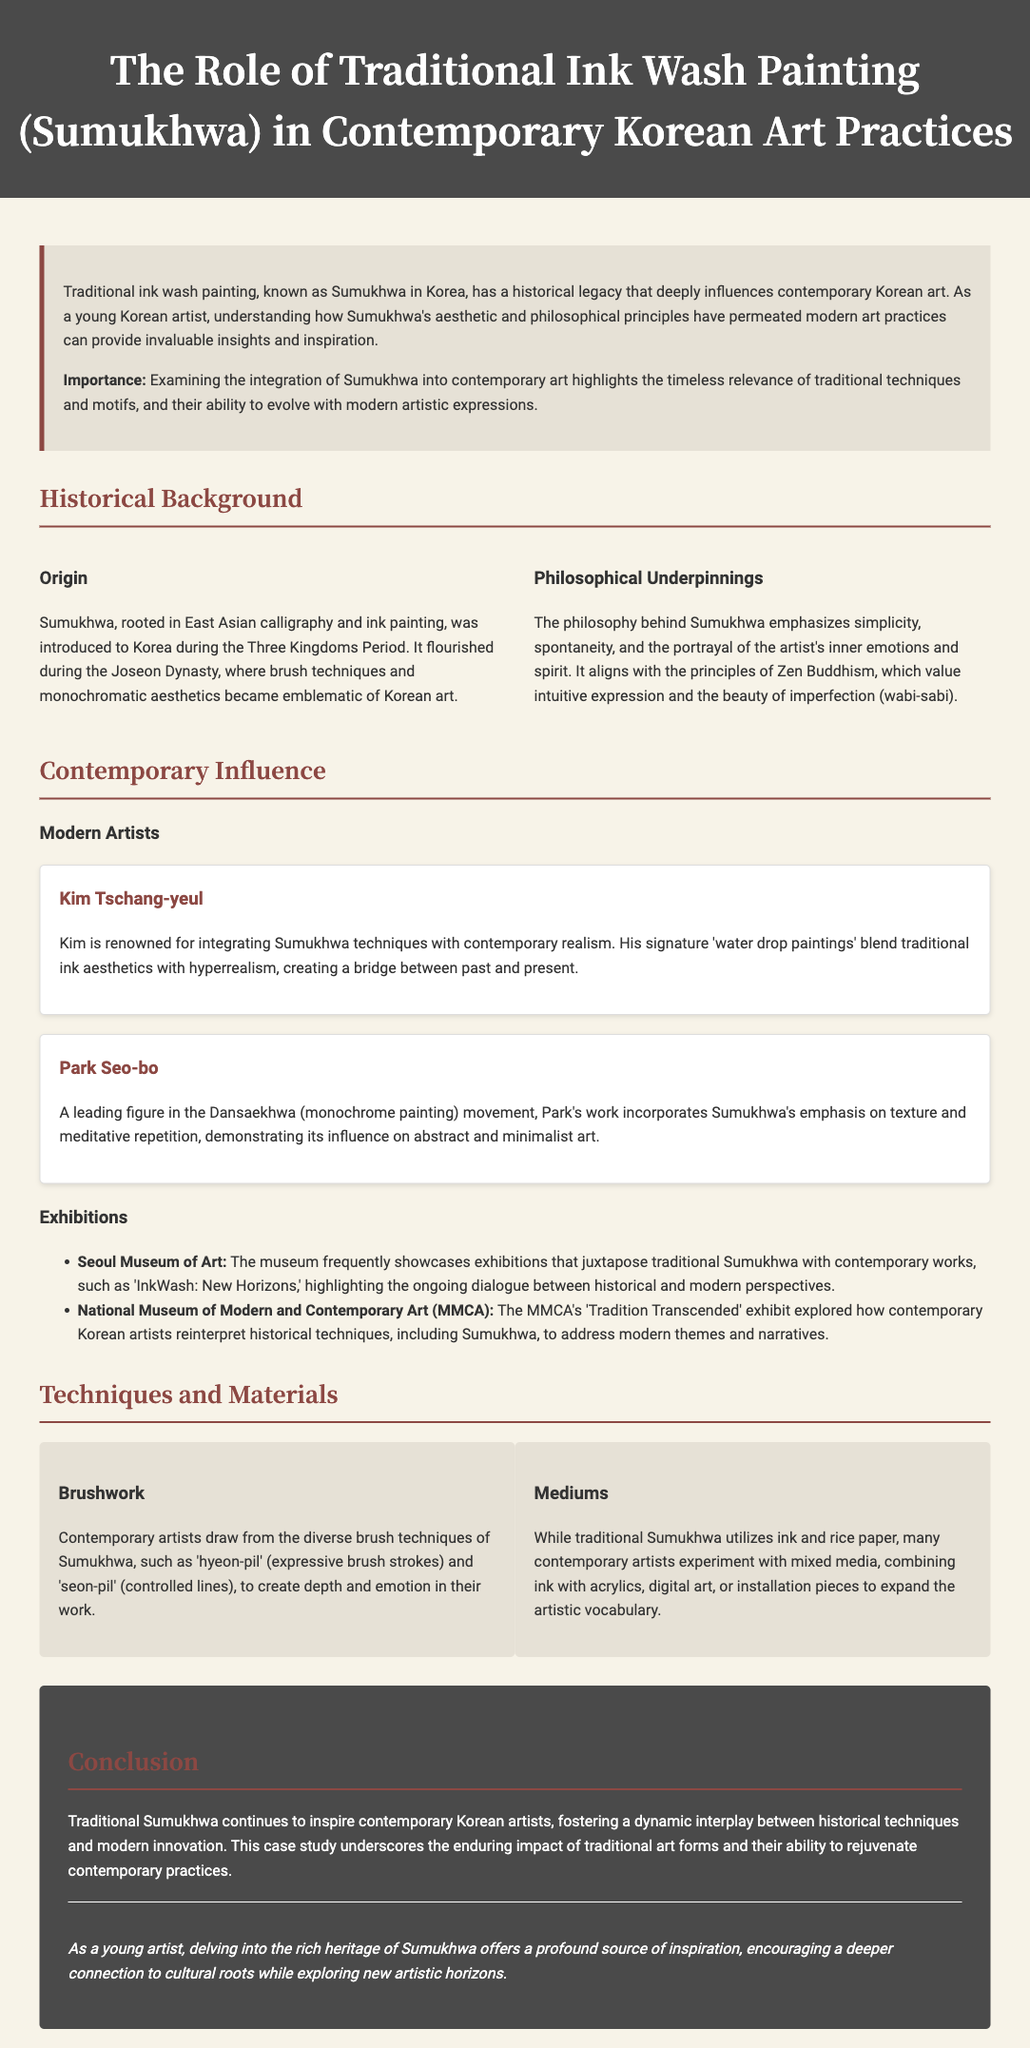What is Sumukhwa? It is the traditional ink wash painting in Korea.
Answer: traditional ink wash painting When was Sumukhwa introduced to Korea? Sumukhwa was introduced during the Three Kingdoms Period.
Answer: Three Kingdoms Period Which dynasty is known for the flourishing of Sumukhwa? The Joseon Dynasty is known for this.
Answer: Joseon Dynasty Who is a leading figure in the Dansaekhwa movement? Park Seo-bo is a leading figure.
Answer: Park Seo-bo What does the philosophy behind Sumukhwa emphasize? It emphasizes simplicity, spontaneity, and inner emotions.
Answer: simplicity, spontaneity, and inner emotions Name one exhibition that showcases the connection between traditional and contemporary art. "InkWash: New Horizons" is one such exhibition.
Answer: InkWash: New Horizons What brush technique is known for expressive strokes? Hyeon-pil is the technique known for this.
Answer: hyeon-pil What materials do contemporary artists combine with traditional ink? They combine ink with acrylics and digital art.
Answer: acrylics and digital art What is the overarching theme of the case study's conclusion? The theme is the enduring impact of traditional art forms.
Answer: enduring impact of traditional art forms 